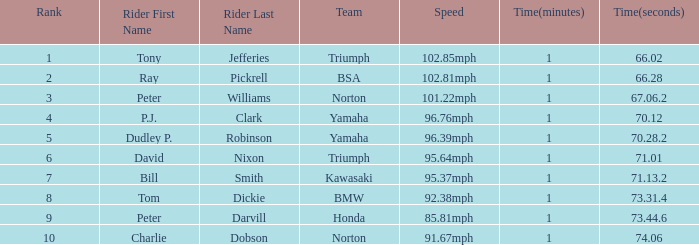At 96.76mph speed, what is the Time? 1:10.12.0. 